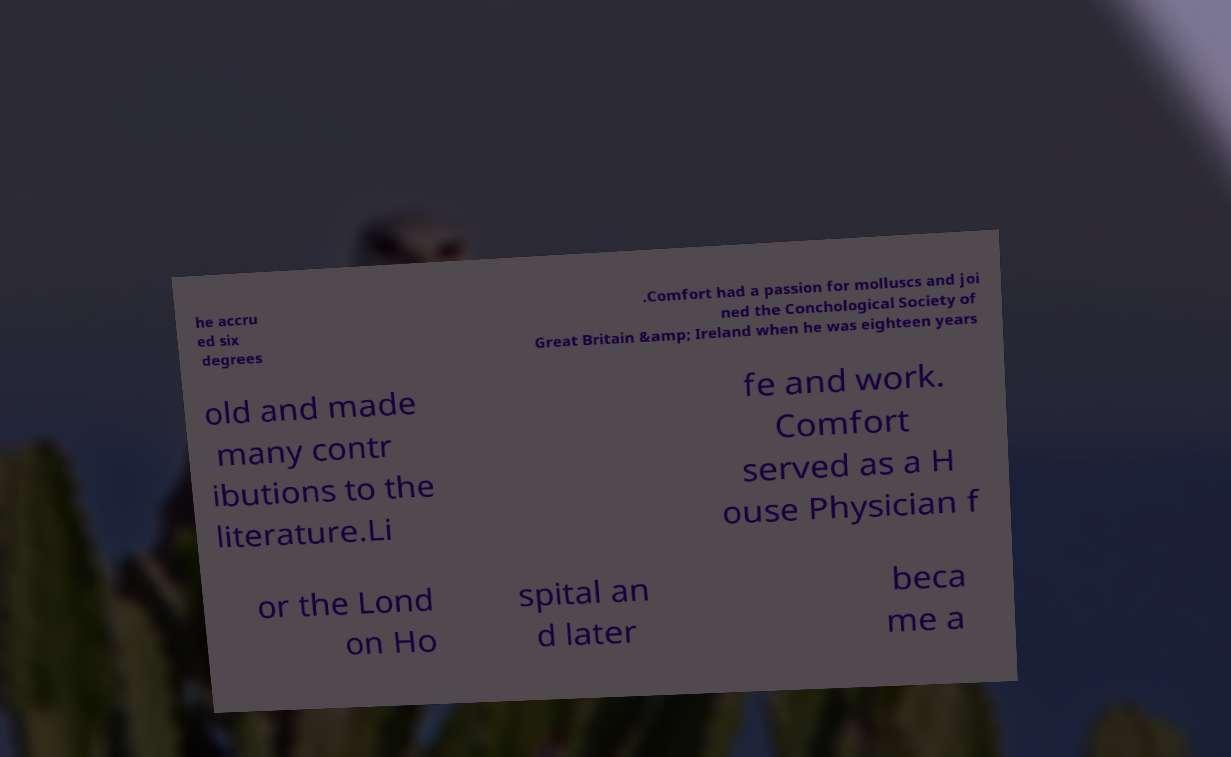Can you read and provide the text displayed in the image?This photo seems to have some interesting text. Can you extract and type it out for me? he accru ed six degrees .Comfort had a passion for molluscs and joi ned the Conchological Society of Great Britain &amp; Ireland when he was eighteen years old and made many contr ibutions to the literature.Li fe and work. Comfort served as a H ouse Physician f or the Lond on Ho spital an d later beca me a 